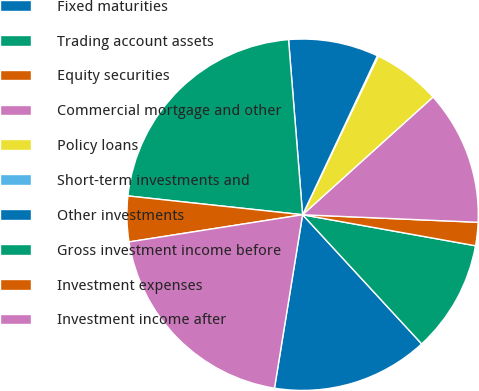Convert chart. <chart><loc_0><loc_0><loc_500><loc_500><pie_chart><fcel>Fixed maturities<fcel>Trading account assets<fcel>Equity securities<fcel>Commercial mortgage and other<fcel>Policy loans<fcel>Short-term investments and<fcel>Other investments<fcel>Gross investment income before<fcel>Investment expenses<fcel>Investment income after<nl><fcel>14.41%<fcel>10.32%<fcel>2.14%<fcel>12.37%<fcel>6.23%<fcel>0.09%<fcel>8.27%<fcel>22.02%<fcel>4.18%<fcel>19.97%<nl></chart> 